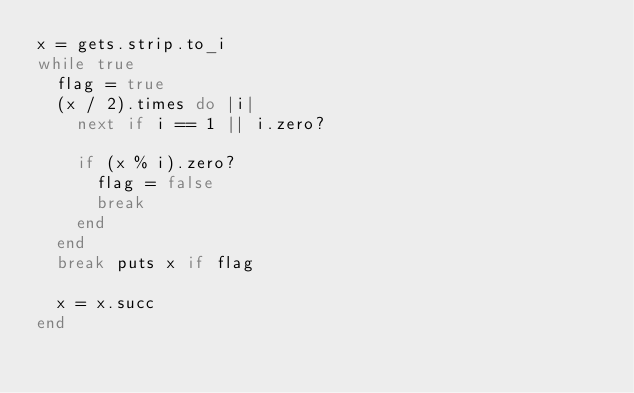<code> <loc_0><loc_0><loc_500><loc_500><_Ruby_>x = gets.strip.to_i
while true
  flag = true
  (x / 2).times do |i|
    next if i == 1 || i.zero?

    if (x % i).zero?
      flag = false
      break
    end
  end
  break puts x if flag

  x = x.succ
end</code> 